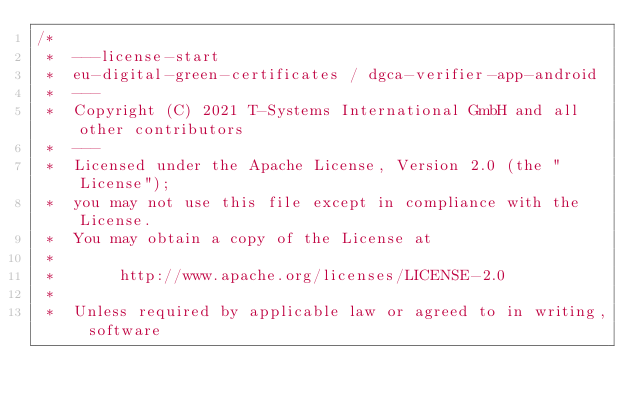Convert code to text. <code><loc_0><loc_0><loc_500><loc_500><_Kotlin_>/*
 *  ---license-start
 *  eu-digital-green-certificates / dgca-verifier-app-android
 *  ---
 *  Copyright (C) 2021 T-Systems International GmbH and all other contributors
 *  ---
 *  Licensed under the Apache License, Version 2.0 (the "License");
 *  you may not use this file except in compliance with the License.
 *  You may obtain a copy of the License at
 *
 *       http://www.apache.org/licenses/LICENSE-2.0
 *
 *  Unless required by applicable law or agreed to in writing, software</code> 